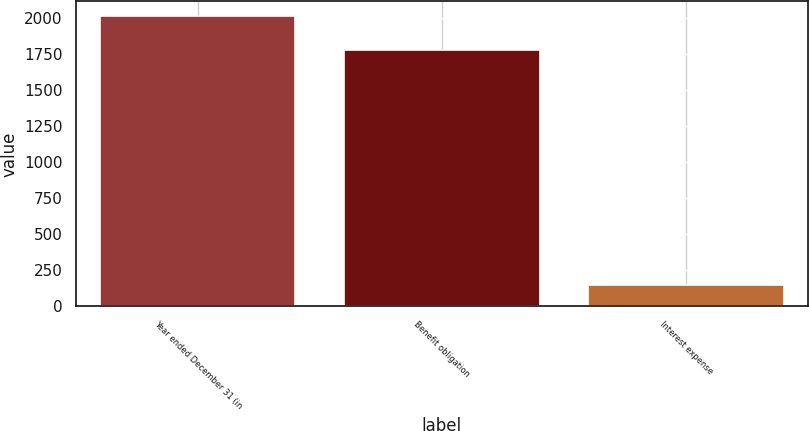Convert chart to OTSL. <chart><loc_0><loc_0><loc_500><loc_500><bar_chart><fcel>Year ended December 31 (in<fcel>Benefit obligation<fcel>Interest expense<nl><fcel>2014<fcel>1774<fcel>149<nl></chart> 